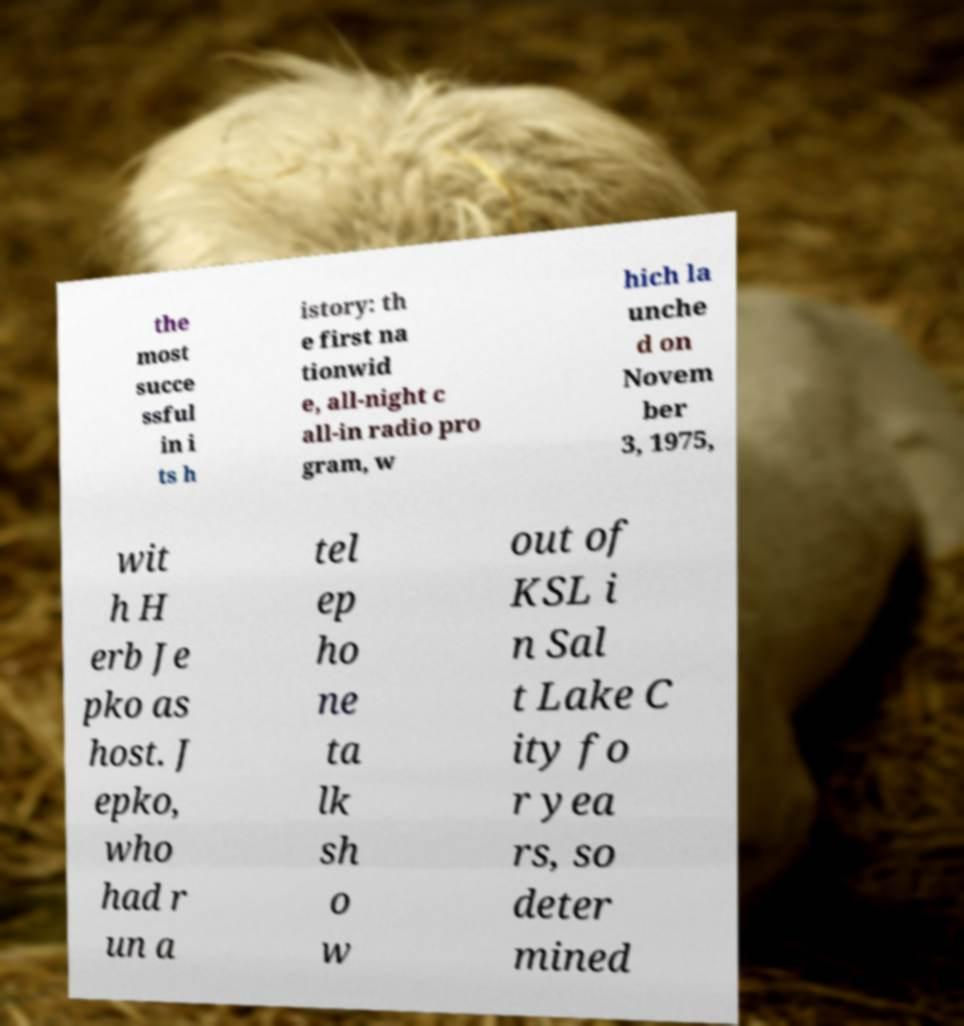There's text embedded in this image that I need extracted. Can you transcribe it verbatim? the most succe ssful in i ts h istory: th e first na tionwid e, all-night c all-in radio pro gram, w hich la unche d on Novem ber 3, 1975, wit h H erb Je pko as host. J epko, who had r un a tel ep ho ne ta lk sh o w out of KSL i n Sal t Lake C ity fo r yea rs, so deter mined 